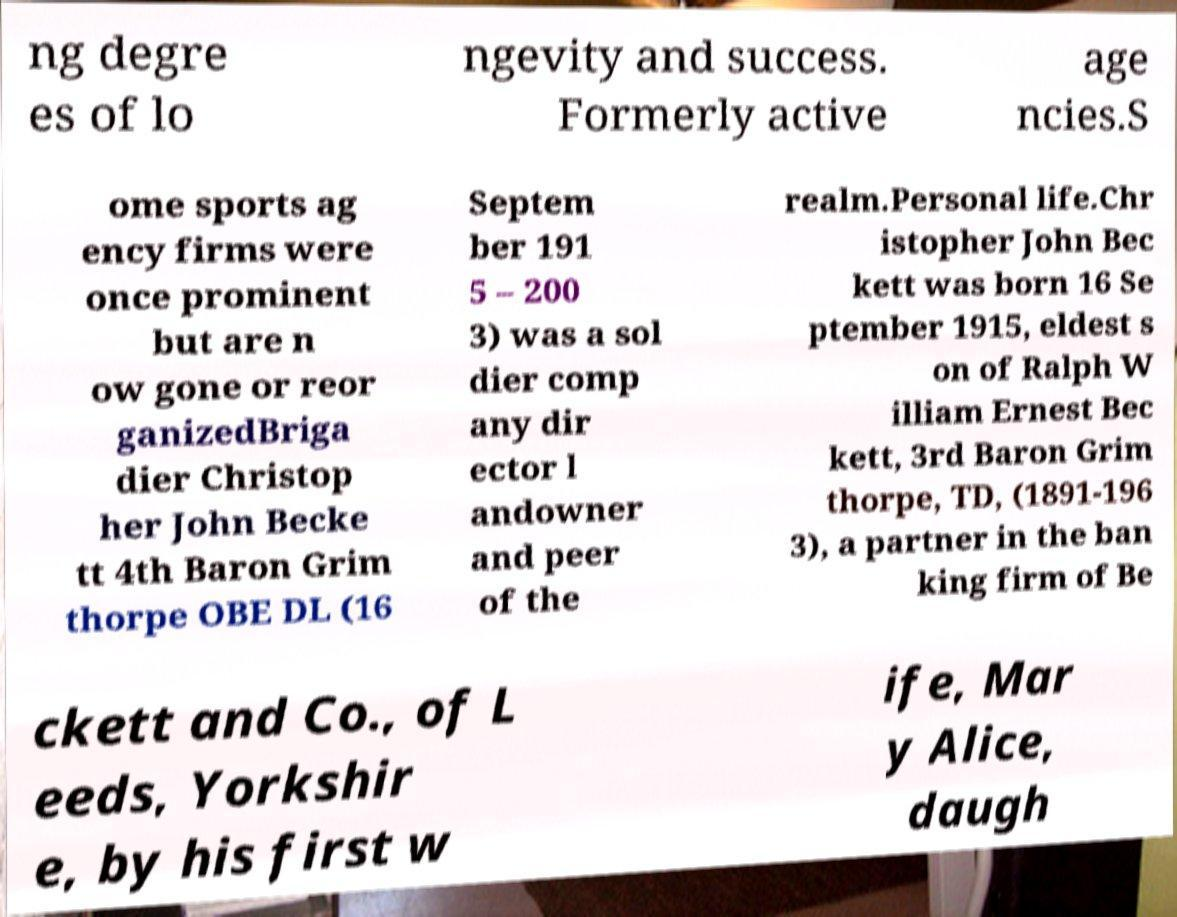There's text embedded in this image that I need extracted. Can you transcribe it verbatim? ng degre es of lo ngevity and success. Formerly active age ncies.S ome sports ag ency firms were once prominent but are n ow gone or reor ganizedBriga dier Christop her John Becke tt 4th Baron Grim thorpe OBE DL (16 Septem ber 191 5 – 200 3) was a sol dier comp any dir ector l andowner and peer of the realm.Personal life.Chr istopher John Bec kett was born 16 Se ptember 1915, eldest s on of Ralph W illiam Ernest Bec kett, 3rd Baron Grim thorpe, TD, (1891-196 3), a partner in the ban king firm of Be ckett and Co., of L eeds, Yorkshir e, by his first w ife, Mar y Alice, daugh 